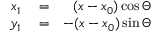<formula> <loc_0><loc_0><loc_500><loc_500>\begin{array} { r l r } { x _ { 1 } } & = } & { ( x - x _ { 0 } ) \cos \Theta } \\ { y _ { 1 } } & = } & { - ( x - x _ { 0 } ) \sin \Theta } \end{array}</formula> 